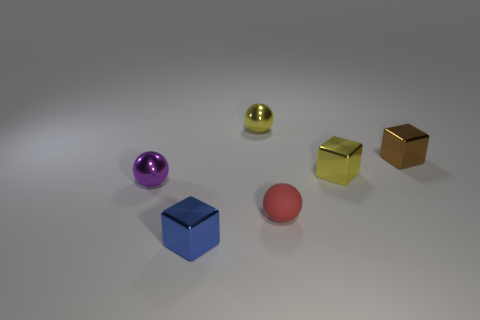Add 3 large gray shiny cylinders. How many objects exist? 9 Subtract all small blue things. Subtract all small blue shiny objects. How many objects are left? 4 Add 2 small yellow things. How many small yellow things are left? 4 Add 5 yellow shiny objects. How many yellow shiny objects exist? 7 Subtract 0 brown balls. How many objects are left? 6 